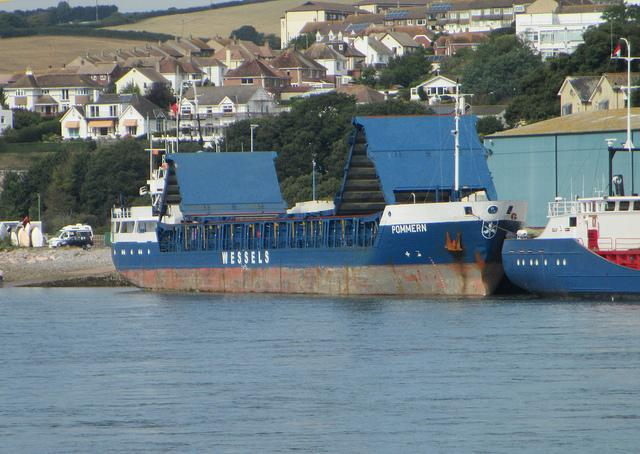The place where these ships are docked is known as? Please explain your reasoning. port. There are several shipping vessels near the shore. 